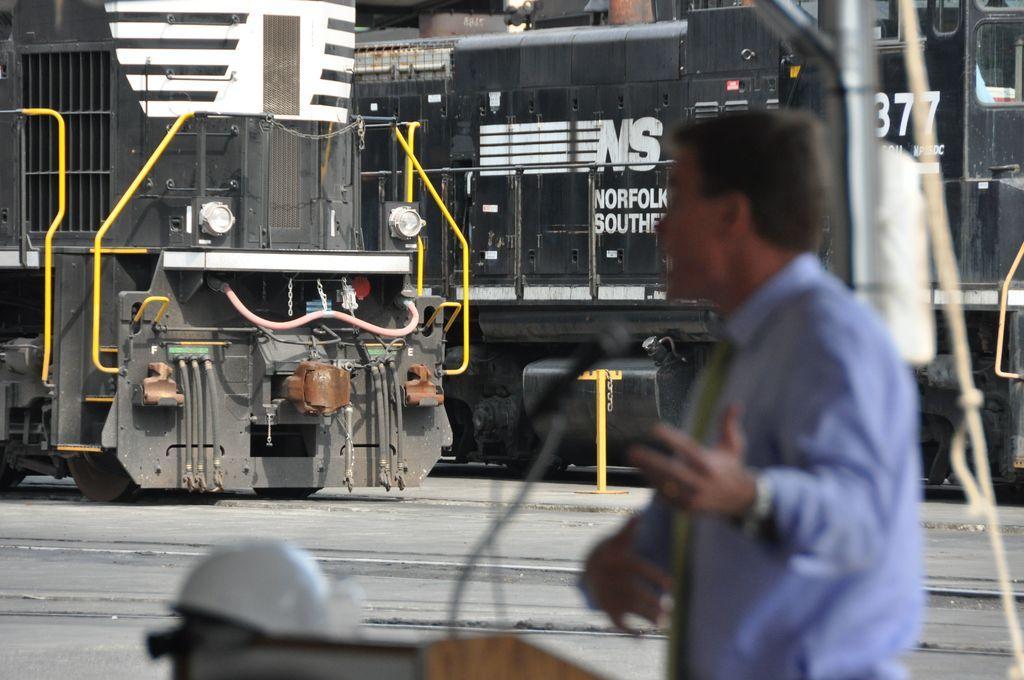Please provide a concise description of this image. In this image we can see a man standing beside a speaker stand containing a helmet and a mic on it. On the backside we can see the trains on the tracks. On the right side we can see a pole and a rope. 